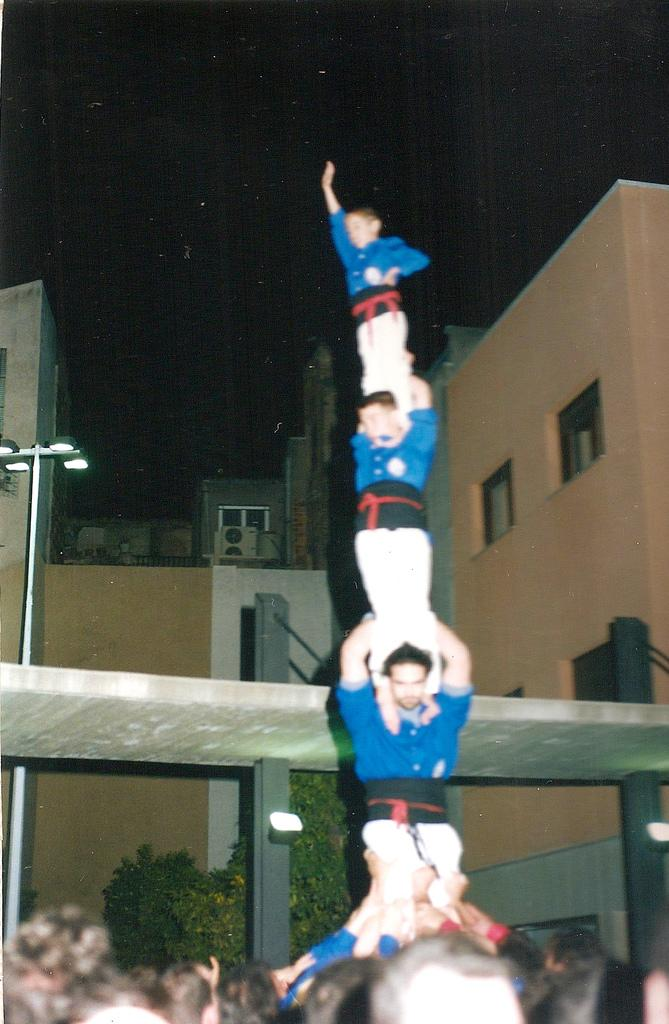Who or what can be seen in the image? There are people in the image. What can be seen illuminating the scene? There are lights visible in the image. What type of vegetation is present in the image? There are plants in the image. What type of structures can be seen in the image? There are buildings in the image. How would you describe the overall lighting in the image? The background of the image is dark. What type of jam is being spread on the stone in the image? There is no jam or stone present in the image. How quiet is the scene in the image? The provided facts do not give any information about the noise level in the image, so it cannot be determined. 